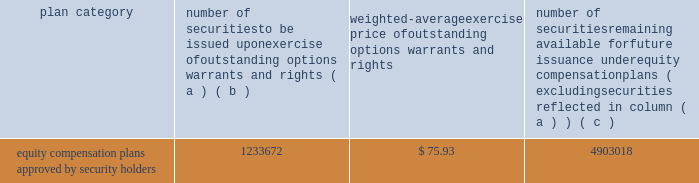Part iii item 10 .
Directors , executive officers and corporate governance for the information required by this item 10 , other than information with respect to our executive officers contained at the end of item 1 of this report , see 201celection of directors , 201d 201cnominees for election to the board of directors , 201d 201ccorporate governance 201d and 201csection 16 ( a ) beneficial ownership reporting compliance , 201d in the proxy statement for our 2015 annual meeting , which information is incorporated herein by reference .
The proxy statement for our 2015 annual meeting will be filed within 120 days of the close of our fiscal year .
For the information required by this item 10 with respect to our executive officers , see part i of this report on pages 11 - 12 .
Item 11 .
Executive compensation for the information required by this item 11 , see 201cexecutive compensation , 201d 201ccompensation committee report on executive compensation 201d and 201ccompensation committee interlocks and insider participation 201d in the proxy statement for our 2015 annual meeting , which information is incorporated herein by reference .
Item 12 .
Security ownership of certain beneficial owners and management and related stockholder matters for the information required by this item 12 with respect to beneficial ownership of our common stock , see 201csecurity ownership of certain beneficial owners and management 201d in the proxy statement for our 2015 annual meeting , which information is incorporated herein by reference .
The table sets forth certain information as of december 31 , 2014 regarding our equity plans : plan category number of securities to be issued upon exercise of outstanding options , warrants and rights weighted-average exercise price of outstanding options , warrants and rights number of securities remaining available for future issuance under equity compensation plans ( excluding securities reflected in column ( a ) ( b ) ( c ) equity compensation plans approved by security holders 1233672 $ 75.93 4903018 item 13 .
Certain relationships and related transactions , and director independence for the information required by this item 13 , see 201ccertain transactions 201d and 201ccorporate governance 201d in the proxy statement for our 2015 annual meeting , which information is incorporated herein by reference .
Item 14 .
Principal accounting fees and services for the information required by this item 14 , see 201caudit and non-audit fees 201d and 201cpolicy on audit committee pre- approval of audit and non-audit services of independent registered public accounting firm 201d in the proxy statement for our 2015 annual meeting , which information is incorporated herein by reference. .
Part iii item 10 .
Directors , executive officers and corporate governance for the information required by this item 10 , other than information with respect to our executive officers contained at the end of item 1 of this report , see 201celection of directors , 201d 201cnominees for election to the board of directors , 201d 201ccorporate governance 201d and 201csection 16 ( a ) beneficial ownership reporting compliance , 201d in the proxy statement for our 2015 annual meeting , which information is incorporated herein by reference .
The proxy statement for our 2015 annual meeting will be filed within 120 days of the close of our fiscal year .
For the information required by this item 10 with respect to our executive officers , see part i of this report on pages 11 - 12 .
Item 11 .
Executive compensation for the information required by this item 11 , see 201cexecutive compensation , 201d 201ccompensation committee report on executive compensation 201d and 201ccompensation committee interlocks and insider participation 201d in the proxy statement for our 2015 annual meeting , which information is incorporated herein by reference .
Item 12 .
Security ownership of certain beneficial owners and management and related stockholder matters for the information required by this item 12 with respect to beneficial ownership of our common stock , see 201csecurity ownership of certain beneficial owners and management 201d in the proxy statement for our 2015 annual meeting , which information is incorporated herein by reference .
The following table sets forth certain information as of december 31 , 2014 regarding our equity plans : plan category number of securities to be issued upon exercise of outstanding options , warrants and rights weighted-average exercise price of outstanding options , warrants and rights number of securities remaining available for future issuance under equity compensation plans ( excluding securities reflected in column ( a ) ( b ) ( c ) equity compensation plans approved by security holders 1233672 $ 75.93 4903018 item 13 .
Certain relationships and related transactions , and director independence for the information required by this item 13 , see 201ccertain transactions 201d and 201ccorporate governance 201d in the proxy statement for our 2015 annual meeting , which information is incorporated herein by reference .
Item 14 .
Principal accounting fees and services for the information required by this item 14 , see 201caudit and non-audit fees 201d and 201cpolicy on audit committee pre- approval of audit and non-audit services of independent registered public accounting firm 201d in the proxy statement for our 2015 annual meeting , which information is incorporated herein by reference. .
What portion of the total number of securities approved by the security holders is issued? 
Computations: (1233672 / (1233672 + 4903018))
Answer: 0.20103. 